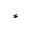<formula> <loc_0><loc_0><loc_500><loc_500>^ { \ast }</formula> 